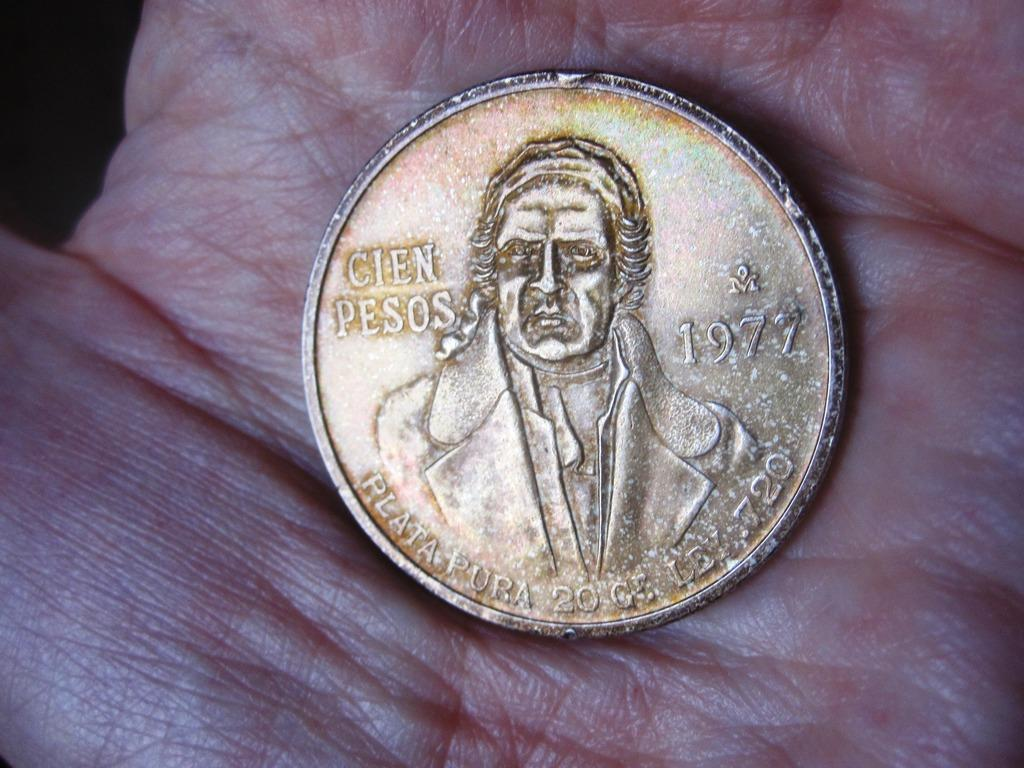Provide a one-sentence caption for the provided image. Coin dated back to 1977 of Cien Pesos. 